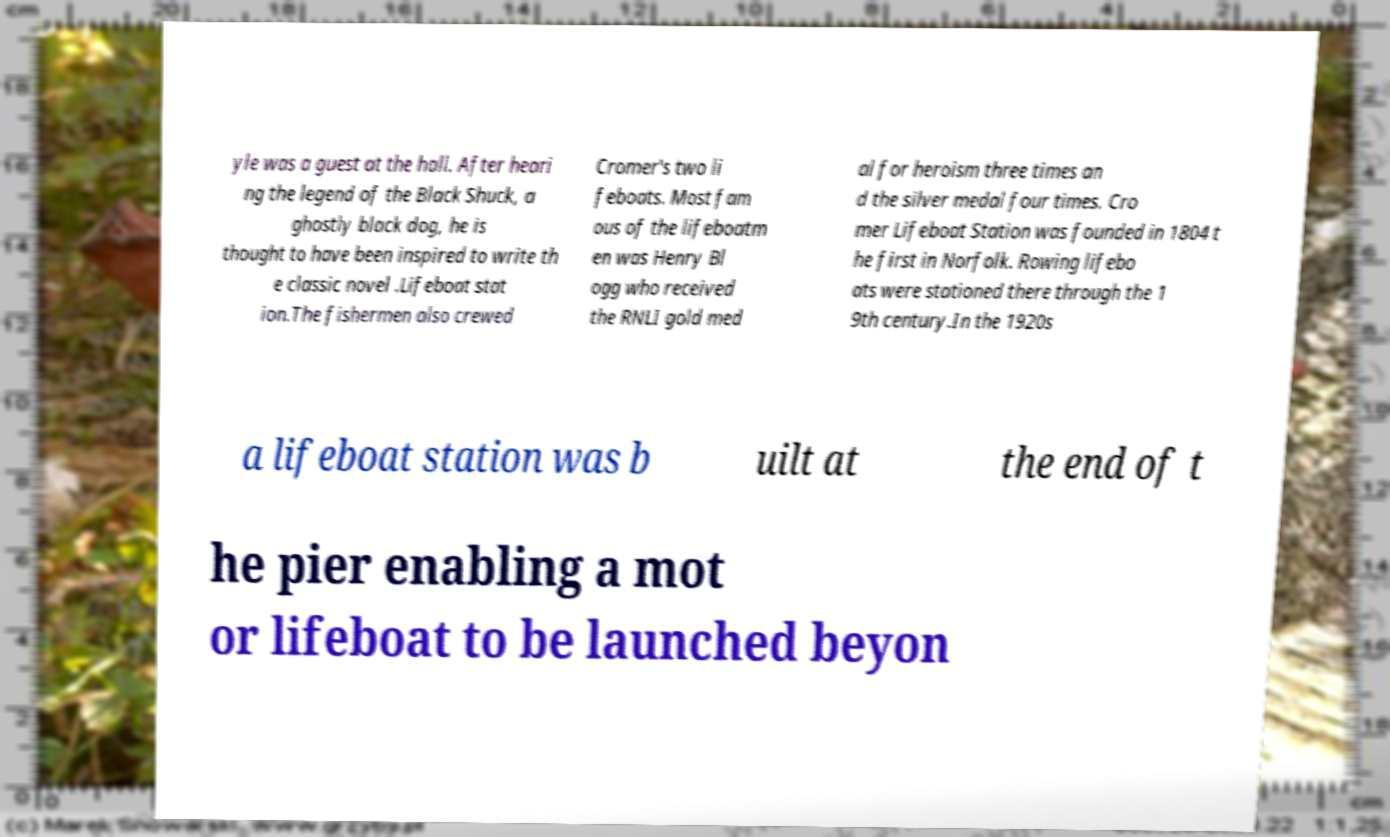Can you read and provide the text displayed in the image?This photo seems to have some interesting text. Can you extract and type it out for me? yle was a guest at the hall. After heari ng the legend of the Black Shuck, a ghostly black dog, he is thought to have been inspired to write th e classic novel .Lifeboat stat ion.The fishermen also crewed Cromer's two li feboats. Most fam ous of the lifeboatm en was Henry Bl ogg who received the RNLI gold med al for heroism three times an d the silver medal four times. Cro mer Lifeboat Station was founded in 1804 t he first in Norfolk. Rowing lifebo ats were stationed there through the 1 9th century.In the 1920s a lifeboat station was b uilt at the end of t he pier enabling a mot or lifeboat to be launched beyon 